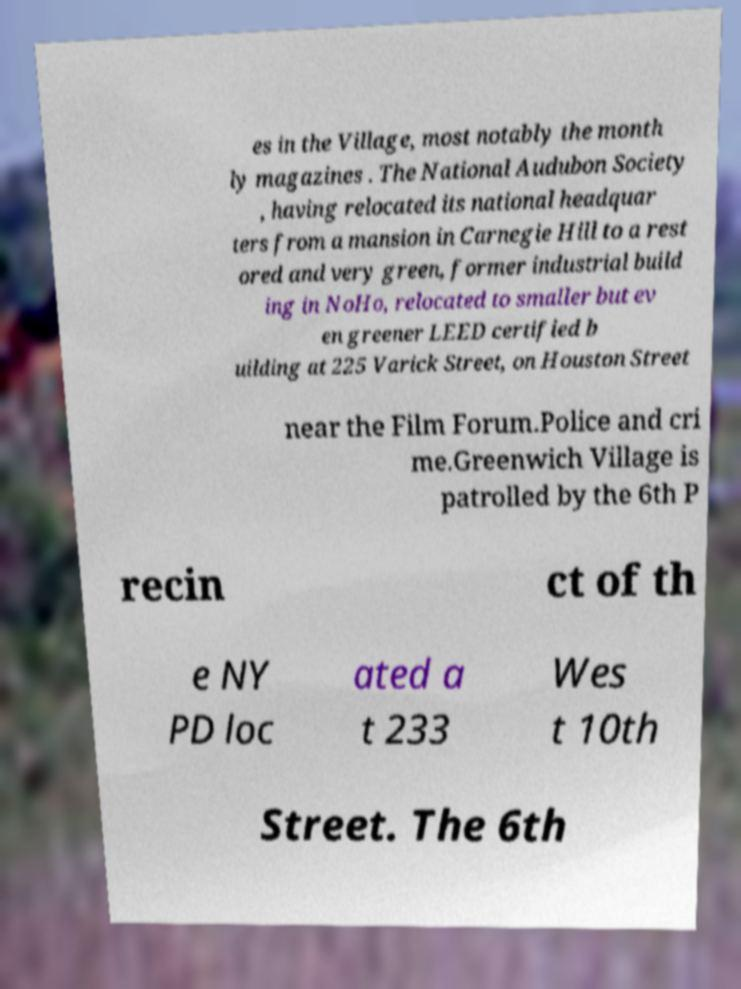I need the written content from this picture converted into text. Can you do that? es in the Village, most notably the month ly magazines . The National Audubon Society , having relocated its national headquar ters from a mansion in Carnegie Hill to a rest ored and very green, former industrial build ing in NoHo, relocated to smaller but ev en greener LEED certified b uilding at 225 Varick Street, on Houston Street near the Film Forum.Police and cri me.Greenwich Village is patrolled by the 6th P recin ct of th e NY PD loc ated a t 233 Wes t 10th Street. The 6th 